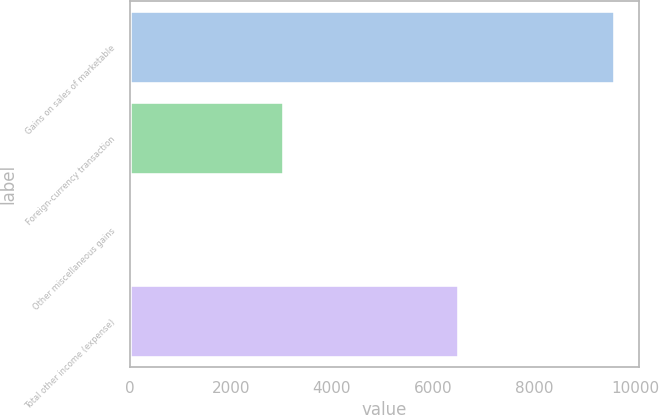<chart> <loc_0><loc_0><loc_500><loc_500><bar_chart><fcel>Gains on sales of marketable<fcel>Foreign-currency transaction<fcel>Other miscellaneous gains<fcel>Total other income (expense)<nl><fcel>9598<fcel>3043<fcel>41<fcel>6514<nl></chart> 